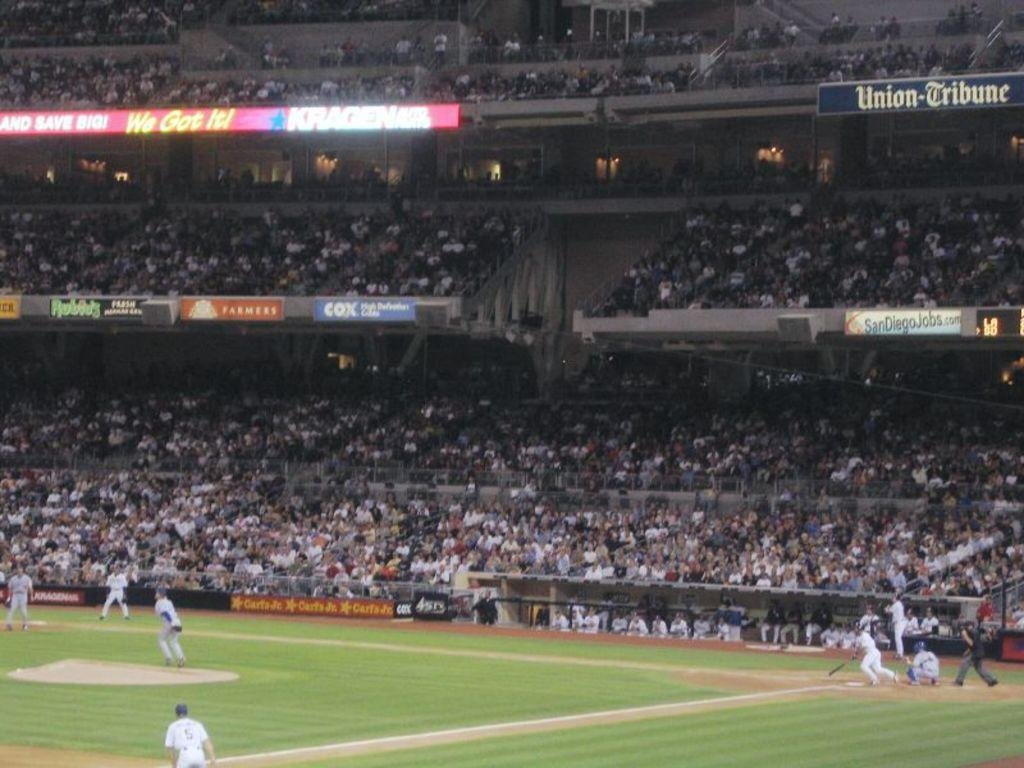<image>
Share a concise interpretation of the image provided. The words we got it can be seen in a baseball field. 